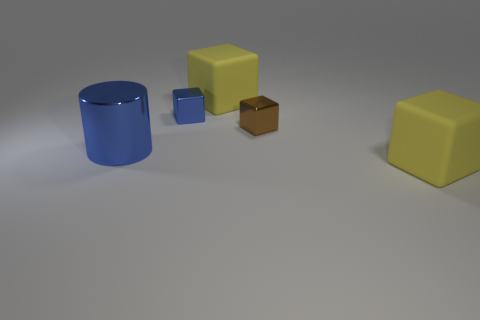Add 3 large cubes. How many objects exist? 8 Subtract all cubes. How many objects are left? 1 Subtract all tiny blue cubes. Subtract all blue cubes. How many objects are left? 3 Add 2 large matte objects. How many large matte objects are left? 4 Add 3 blue things. How many blue things exist? 5 Subtract 0 brown cylinders. How many objects are left? 5 